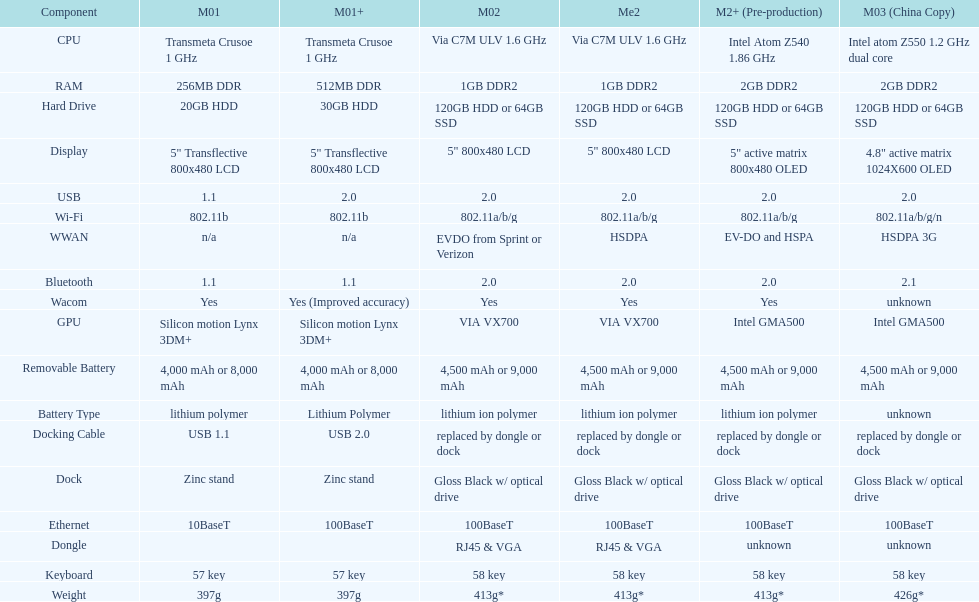Are there at least 13 different components on the chart? Yes. 